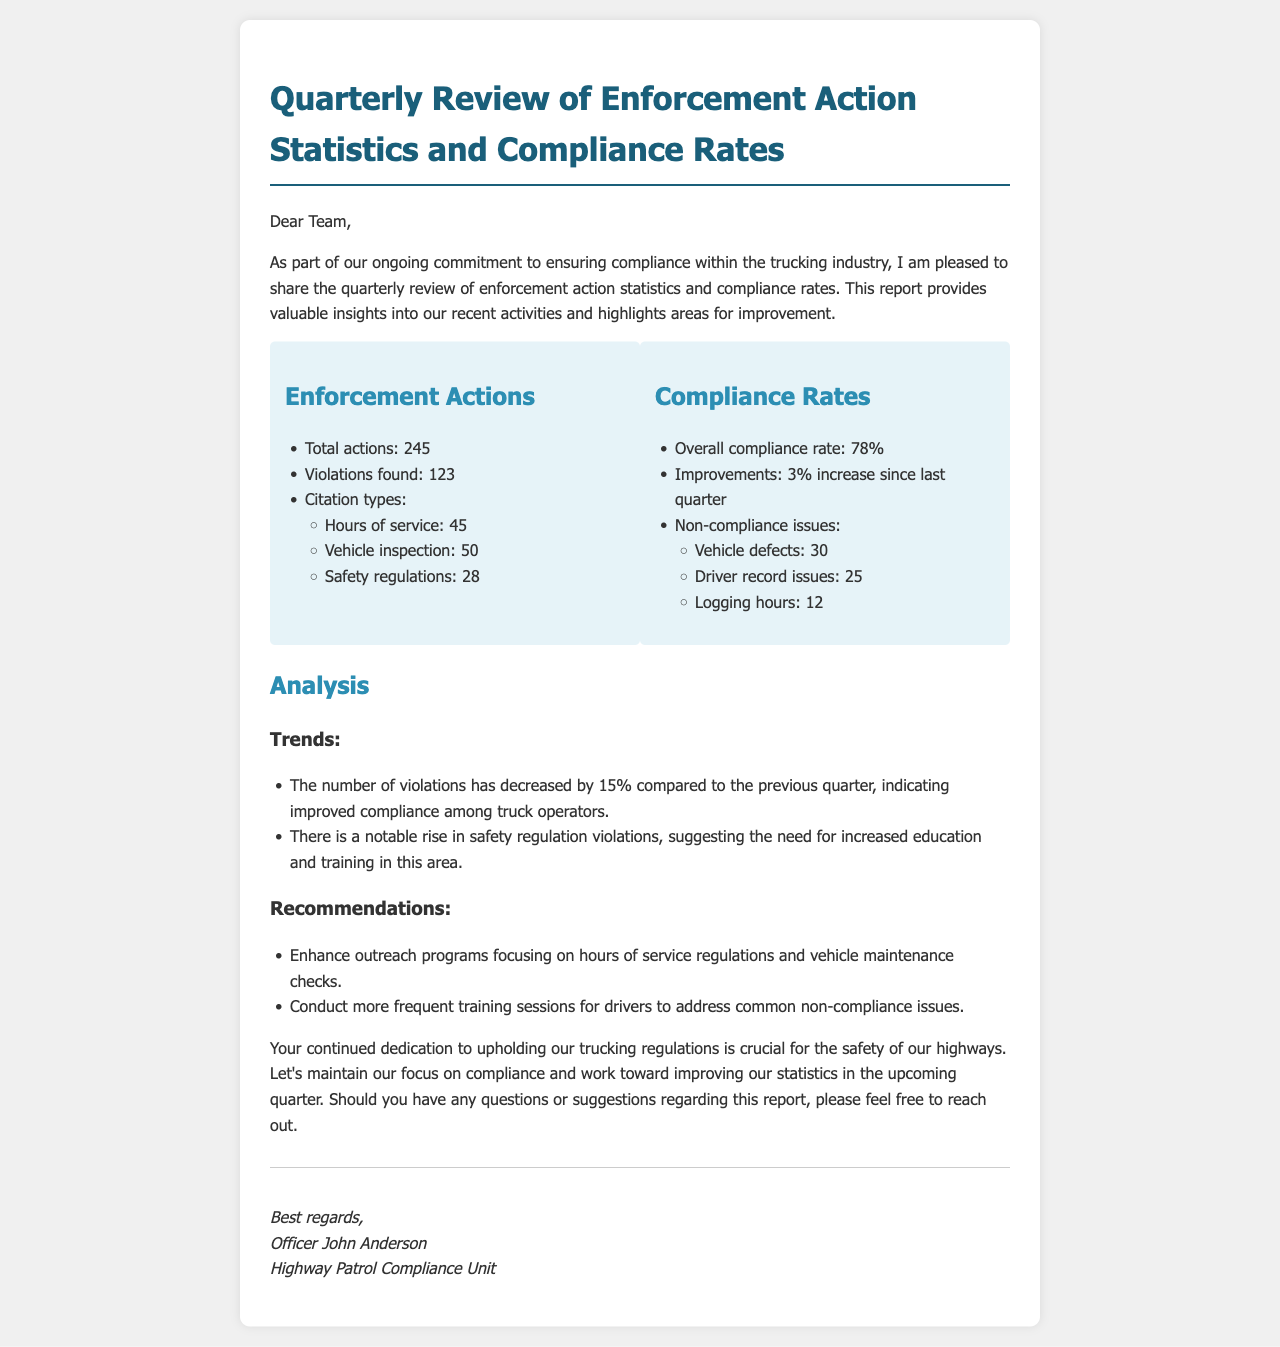What is the total number of enforcement actions? The total number of enforcement actions is stated directly in the document, which is 245.
Answer: 245 What is the overall compliance rate? The overall compliance rate is clearly mentioned in the document as 78%.
Answer: 78% How much has the compliance rate improved since last quarter? The document specifies that there has been a 3% increase in the compliance rate since last quarter.
Answer: 3% What type of violation had the highest count? Within the citation types listed, vehicle inspection has the highest count, which is 50.
Answer: Vehicle inspection What are the three non-compliance issues listed? The document lists vehicle defects, driver record issues, and logging hours as the three non-compliance issues.
Answer: Vehicle defects, driver record issues, logging hours What trend is noted regarding the number of violations? The document states that the number of violations has decreased by 15% compared to the previous quarter.
Answer: Decreased by 15% What is one recommendation made in the document? The document provides several recommendations, one of which is to enhance outreach programs focusing on hours of service regulations.
Answer: Enhance outreach programs Who is the author of the report? The document contains the signature of the officer who authored the report, which is Officer John Anderson.
Answer: Officer John Anderson 